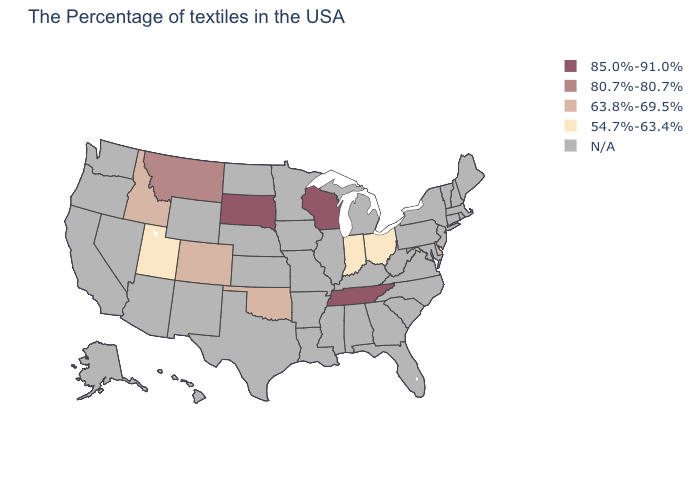What is the lowest value in the USA?
Answer briefly. 54.7%-63.4%. Does the first symbol in the legend represent the smallest category?
Be succinct. No. Is the legend a continuous bar?
Short answer required. No. Among the states that border New Jersey , which have the lowest value?
Write a very short answer. Delaware. What is the value of New Mexico?
Concise answer only. N/A. Name the states that have a value in the range N/A?
Give a very brief answer. Maine, Massachusetts, Rhode Island, New Hampshire, Vermont, Connecticut, New York, New Jersey, Maryland, Pennsylvania, Virginia, North Carolina, South Carolina, West Virginia, Florida, Georgia, Michigan, Kentucky, Alabama, Illinois, Mississippi, Louisiana, Missouri, Arkansas, Minnesota, Iowa, Kansas, Nebraska, Texas, North Dakota, Wyoming, New Mexico, Arizona, Nevada, California, Washington, Oregon, Alaska, Hawaii. Does Wisconsin have the highest value in the MidWest?
Be succinct. Yes. Name the states that have a value in the range 54.7%-63.4%?
Give a very brief answer. Ohio, Indiana, Utah. What is the value of Louisiana?
Short answer required. N/A. What is the lowest value in the West?
Be succinct. 54.7%-63.4%. What is the lowest value in the USA?
Concise answer only. 54.7%-63.4%. What is the value of New Hampshire?
Give a very brief answer. N/A. Does Tennessee have the highest value in the USA?
Answer briefly. Yes. 